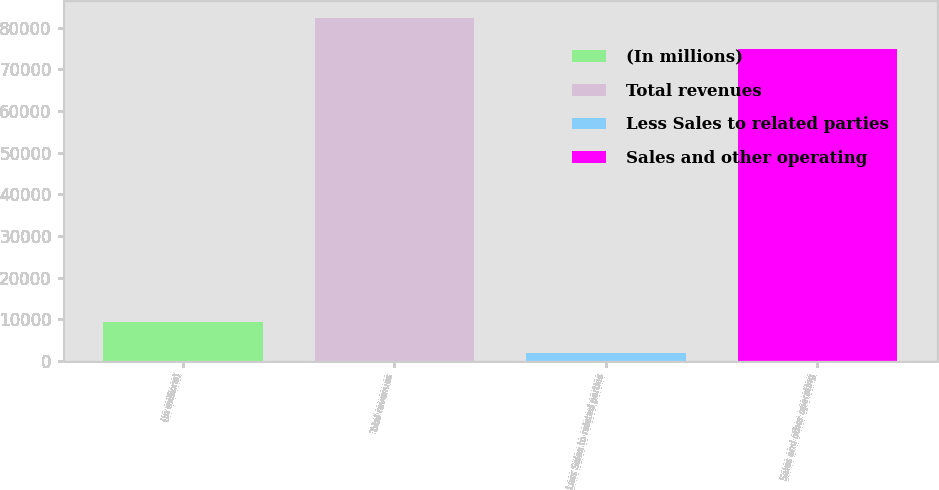Convert chart to OTSL. <chart><loc_0><loc_0><loc_500><loc_500><bar_chart><fcel>(In millions)<fcel>Total revenues<fcel>Less Sales to related parties<fcel>Sales and other operating<nl><fcel>9366.5<fcel>82362.5<fcel>1879<fcel>74875<nl></chart> 